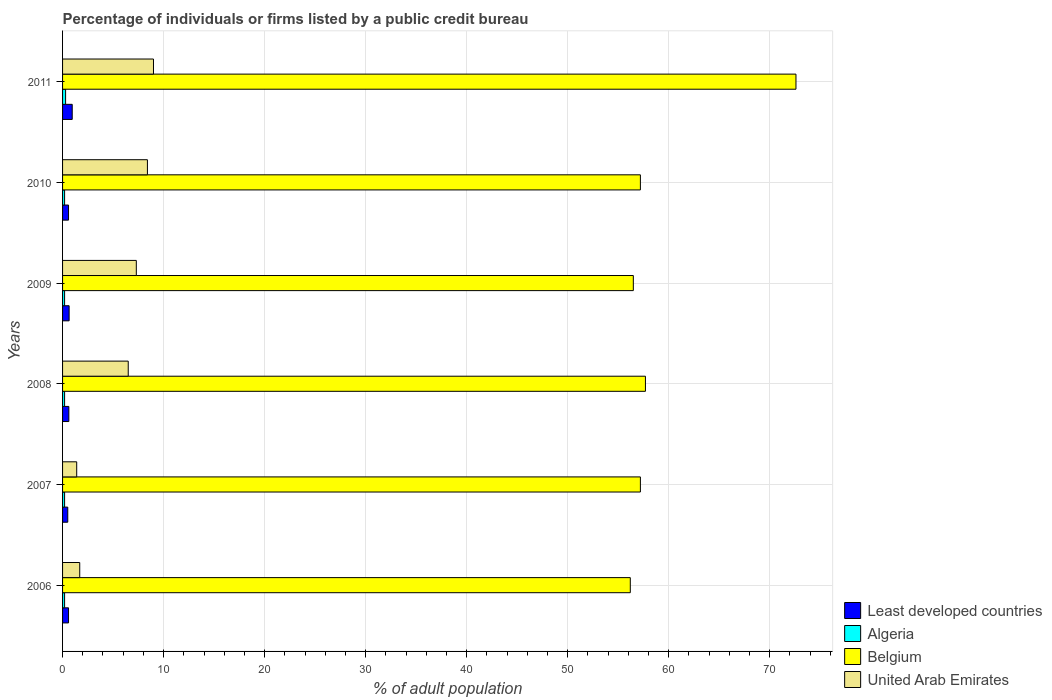How many bars are there on the 6th tick from the top?
Your answer should be compact. 4. How many bars are there on the 6th tick from the bottom?
Your answer should be very brief. 4. In how many cases, is the number of bars for a given year not equal to the number of legend labels?
Ensure brevity in your answer.  0. What is the percentage of population listed by a public credit bureau in Algeria in 2006?
Your response must be concise. 0.2. Across all years, what is the minimum percentage of population listed by a public credit bureau in United Arab Emirates?
Offer a very short reply. 1.4. What is the total percentage of population listed by a public credit bureau in United Arab Emirates in the graph?
Your answer should be very brief. 34.3. What is the difference between the percentage of population listed by a public credit bureau in Belgium in 2008 and that in 2009?
Your answer should be compact. 1.2. What is the difference between the percentage of population listed by a public credit bureau in Belgium in 2011 and the percentage of population listed by a public credit bureau in United Arab Emirates in 2008?
Keep it short and to the point. 66.1. What is the average percentage of population listed by a public credit bureau in Algeria per year?
Keep it short and to the point. 0.22. In the year 2011, what is the difference between the percentage of population listed by a public credit bureau in Belgium and percentage of population listed by a public credit bureau in Algeria?
Offer a very short reply. 72.3. What is the ratio of the percentage of population listed by a public credit bureau in Least developed countries in 2009 to that in 2010?
Your answer should be very brief. 1.1. Is the percentage of population listed by a public credit bureau in Belgium in 2009 less than that in 2010?
Your answer should be compact. Yes. What is the difference between the highest and the second highest percentage of population listed by a public credit bureau in Algeria?
Offer a terse response. 0.1. What is the difference between the highest and the lowest percentage of population listed by a public credit bureau in Belgium?
Your response must be concise. 16.4. Is it the case that in every year, the sum of the percentage of population listed by a public credit bureau in United Arab Emirates and percentage of population listed by a public credit bureau in Least developed countries is greater than the sum of percentage of population listed by a public credit bureau in Algeria and percentage of population listed by a public credit bureau in Belgium?
Provide a short and direct response. Yes. What does the 4th bar from the top in 2008 represents?
Your response must be concise. Least developed countries. What does the 1st bar from the bottom in 2009 represents?
Your answer should be compact. Least developed countries. Are all the bars in the graph horizontal?
Provide a short and direct response. Yes. How many years are there in the graph?
Give a very brief answer. 6. What is the difference between two consecutive major ticks on the X-axis?
Offer a very short reply. 10. How many legend labels are there?
Keep it short and to the point. 4. What is the title of the graph?
Give a very brief answer. Percentage of individuals or firms listed by a public credit bureau. Does "Middle East & North Africa (developing only)" appear as one of the legend labels in the graph?
Offer a very short reply. No. What is the label or title of the X-axis?
Offer a very short reply. % of adult population. What is the % of adult population in Least developed countries in 2006?
Make the answer very short. 0.59. What is the % of adult population of Algeria in 2006?
Provide a succinct answer. 0.2. What is the % of adult population of Belgium in 2006?
Keep it short and to the point. 56.2. What is the % of adult population of United Arab Emirates in 2006?
Provide a succinct answer. 1.7. What is the % of adult population in Least developed countries in 2007?
Offer a very short reply. 0.51. What is the % of adult population of Belgium in 2007?
Your answer should be compact. 57.2. What is the % of adult population of Least developed countries in 2008?
Keep it short and to the point. 0.62. What is the % of adult population in Belgium in 2008?
Ensure brevity in your answer.  57.7. What is the % of adult population in United Arab Emirates in 2008?
Give a very brief answer. 6.5. What is the % of adult population in Least developed countries in 2009?
Your answer should be very brief. 0.65. What is the % of adult population in Algeria in 2009?
Ensure brevity in your answer.  0.2. What is the % of adult population of Belgium in 2009?
Make the answer very short. 56.5. What is the % of adult population in United Arab Emirates in 2009?
Make the answer very short. 7.3. What is the % of adult population of Least developed countries in 2010?
Give a very brief answer. 0.59. What is the % of adult population in Belgium in 2010?
Offer a terse response. 57.2. What is the % of adult population of United Arab Emirates in 2010?
Your response must be concise. 8.4. What is the % of adult population of Least developed countries in 2011?
Your response must be concise. 0.96. What is the % of adult population of Belgium in 2011?
Offer a very short reply. 72.6. What is the % of adult population of United Arab Emirates in 2011?
Offer a very short reply. 9. Across all years, what is the maximum % of adult population in Least developed countries?
Your answer should be compact. 0.96. Across all years, what is the maximum % of adult population of Belgium?
Keep it short and to the point. 72.6. Across all years, what is the maximum % of adult population in United Arab Emirates?
Ensure brevity in your answer.  9. Across all years, what is the minimum % of adult population of Least developed countries?
Offer a terse response. 0.51. Across all years, what is the minimum % of adult population of Algeria?
Provide a succinct answer. 0.2. Across all years, what is the minimum % of adult population in Belgium?
Make the answer very short. 56.2. Across all years, what is the minimum % of adult population of United Arab Emirates?
Keep it short and to the point. 1.4. What is the total % of adult population in Least developed countries in the graph?
Your response must be concise. 3.92. What is the total % of adult population in Belgium in the graph?
Make the answer very short. 357.4. What is the total % of adult population in United Arab Emirates in the graph?
Provide a succinct answer. 34.3. What is the difference between the % of adult population of Least developed countries in 2006 and that in 2007?
Give a very brief answer. 0.08. What is the difference between the % of adult population of Algeria in 2006 and that in 2007?
Make the answer very short. 0. What is the difference between the % of adult population in Belgium in 2006 and that in 2007?
Offer a very short reply. -1. What is the difference between the % of adult population in United Arab Emirates in 2006 and that in 2007?
Offer a very short reply. 0.3. What is the difference between the % of adult population in Least developed countries in 2006 and that in 2008?
Your answer should be very brief. -0.03. What is the difference between the % of adult population of Algeria in 2006 and that in 2008?
Ensure brevity in your answer.  0. What is the difference between the % of adult population of Least developed countries in 2006 and that in 2009?
Give a very brief answer. -0.06. What is the difference between the % of adult population of Algeria in 2006 and that in 2009?
Keep it short and to the point. 0. What is the difference between the % of adult population of Algeria in 2006 and that in 2010?
Keep it short and to the point. 0. What is the difference between the % of adult population of Belgium in 2006 and that in 2010?
Your response must be concise. -1. What is the difference between the % of adult population of Least developed countries in 2006 and that in 2011?
Provide a short and direct response. -0.37. What is the difference between the % of adult population of Belgium in 2006 and that in 2011?
Your answer should be compact. -16.4. What is the difference between the % of adult population in United Arab Emirates in 2006 and that in 2011?
Provide a short and direct response. -7.3. What is the difference between the % of adult population in Least developed countries in 2007 and that in 2008?
Keep it short and to the point. -0.11. What is the difference between the % of adult population of Algeria in 2007 and that in 2008?
Provide a short and direct response. 0. What is the difference between the % of adult population of Least developed countries in 2007 and that in 2009?
Ensure brevity in your answer.  -0.13. What is the difference between the % of adult population of Algeria in 2007 and that in 2009?
Offer a terse response. 0. What is the difference between the % of adult population of Belgium in 2007 and that in 2009?
Your response must be concise. 0.7. What is the difference between the % of adult population of United Arab Emirates in 2007 and that in 2009?
Your answer should be compact. -5.9. What is the difference between the % of adult population in Least developed countries in 2007 and that in 2010?
Offer a very short reply. -0.08. What is the difference between the % of adult population of Least developed countries in 2007 and that in 2011?
Keep it short and to the point. -0.44. What is the difference between the % of adult population of Algeria in 2007 and that in 2011?
Provide a short and direct response. -0.1. What is the difference between the % of adult population of Belgium in 2007 and that in 2011?
Keep it short and to the point. -15.4. What is the difference between the % of adult population in Least developed countries in 2008 and that in 2009?
Make the answer very short. -0.03. What is the difference between the % of adult population of Least developed countries in 2008 and that in 2010?
Ensure brevity in your answer.  0.03. What is the difference between the % of adult population of Algeria in 2008 and that in 2010?
Ensure brevity in your answer.  0. What is the difference between the % of adult population of Least developed countries in 2008 and that in 2011?
Give a very brief answer. -0.33. What is the difference between the % of adult population of Belgium in 2008 and that in 2011?
Offer a terse response. -14.9. What is the difference between the % of adult population in United Arab Emirates in 2008 and that in 2011?
Offer a terse response. -2.5. What is the difference between the % of adult population of Least developed countries in 2009 and that in 2010?
Make the answer very short. 0.06. What is the difference between the % of adult population in Algeria in 2009 and that in 2010?
Offer a very short reply. 0. What is the difference between the % of adult population in Belgium in 2009 and that in 2010?
Offer a terse response. -0.7. What is the difference between the % of adult population of Least developed countries in 2009 and that in 2011?
Your answer should be very brief. -0.31. What is the difference between the % of adult population of Belgium in 2009 and that in 2011?
Your answer should be very brief. -16.1. What is the difference between the % of adult population of Least developed countries in 2010 and that in 2011?
Make the answer very short. -0.37. What is the difference between the % of adult population in Belgium in 2010 and that in 2011?
Keep it short and to the point. -15.4. What is the difference between the % of adult population in United Arab Emirates in 2010 and that in 2011?
Your answer should be compact. -0.6. What is the difference between the % of adult population in Least developed countries in 2006 and the % of adult population in Algeria in 2007?
Give a very brief answer. 0.39. What is the difference between the % of adult population in Least developed countries in 2006 and the % of adult population in Belgium in 2007?
Offer a very short reply. -56.61. What is the difference between the % of adult population of Least developed countries in 2006 and the % of adult population of United Arab Emirates in 2007?
Your answer should be compact. -0.81. What is the difference between the % of adult population of Algeria in 2006 and the % of adult population of Belgium in 2007?
Provide a succinct answer. -57. What is the difference between the % of adult population of Algeria in 2006 and the % of adult population of United Arab Emirates in 2007?
Your response must be concise. -1.2. What is the difference between the % of adult population in Belgium in 2006 and the % of adult population in United Arab Emirates in 2007?
Offer a very short reply. 54.8. What is the difference between the % of adult population in Least developed countries in 2006 and the % of adult population in Algeria in 2008?
Give a very brief answer. 0.39. What is the difference between the % of adult population of Least developed countries in 2006 and the % of adult population of Belgium in 2008?
Offer a terse response. -57.11. What is the difference between the % of adult population in Least developed countries in 2006 and the % of adult population in United Arab Emirates in 2008?
Your answer should be very brief. -5.91. What is the difference between the % of adult population of Algeria in 2006 and the % of adult population of Belgium in 2008?
Your answer should be very brief. -57.5. What is the difference between the % of adult population in Belgium in 2006 and the % of adult population in United Arab Emirates in 2008?
Provide a short and direct response. 49.7. What is the difference between the % of adult population in Least developed countries in 2006 and the % of adult population in Algeria in 2009?
Your answer should be compact. 0.39. What is the difference between the % of adult population in Least developed countries in 2006 and the % of adult population in Belgium in 2009?
Give a very brief answer. -55.91. What is the difference between the % of adult population of Least developed countries in 2006 and the % of adult population of United Arab Emirates in 2009?
Offer a very short reply. -6.71. What is the difference between the % of adult population in Algeria in 2006 and the % of adult population in Belgium in 2009?
Offer a very short reply. -56.3. What is the difference between the % of adult population in Algeria in 2006 and the % of adult population in United Arab Emirates in 2009?
Provide a succinct answer. -7.1. What is the difference between the % of adult population of Belgium in 2006 and the % of adult population of United Arab Emirates in 2009?
Your answer should be compact. 48.9. What is the difference between the % of adult population of Least developed countries in 2006 and the % of adult population of Algeria in 2010?
Ensure brevity in your answer.  0.39. What is the difference between the % of adult population of Least developed countries in 2006 and the % of adult population of Belgium in 2010?
Provide a short and direct response. -56.61. What is the difference between the % of adult population in Least developed countries in 2006 and the % of adult population in United Arab Emirates in 2010?
Keep it short and to the point. -7.81. What is the difference between the % of adult population of Algeria in 2006 and the % of adult population of Belgium in 2010?
Ensure brevity in your answer.  -57. What is the difference between the % of adult population of Algeria in 2006 and the % of adult population of United Arab Emirates in 2010?
Your answer should be very brief. -8.2. What is the difference between the % of adult population in Belgium in 2006 and the % of adult population in United Arab Emirates in 2010?
Provide a succinct answer. 47.8. What is the difference between the % of adult population in Least developed countries in 2006 and the % of adult population in Algeria in 2011?
Offer a terse response. 0.29. What is the difference between the % of adult population in Least developed countries in 2006 and the % of adult population in Belgium in 2011?
Keep it short and to the point. -72.01. What is the difference between the % of adult population in Least developed countries in 2006 and the % of adult population in United Arab Emirates in 2011?
Ensure brevity in your answer.  -8.41. What is the difference between the % of adult population of Algeria in 2006 and the % of adult population of Belgium in 2011?
Your answer should be compact. -72.4. What is the difference between the % of adult population in Belgium in 2006 and the % of adult population in United Arab Emirates in 2011?
Ensure brevity in your answer.  47.2. What is the difference between the % of adult population in Least developed countries in 2007 and the % of adult population in Algeria in 2008?
Your answer should be very brief. 0.31. What is the difference between the % of adult population in Least developed countries in 2007 and the % of adult population in Belgium in 2008?
Give a very brief answer. -57.19. What is the difference between the % of adult population in Least developed countries in 2007 and the % of adult population in United Arab Emirates in 2008?
Offer a terse response. -5.99. What is the difference between the % of adult population in Algeria in 2007 and the % of adult population in Belgium in 2008?
Your answer should be compact. -57.5. What is the difference between the % of adult population in Belgium in 2007 and the % of adult population in United Arab Emirates in 2008?
Give a very brief answer. 50.7. What is the difference between the % of adult population of Least developed countries in 2007 and the % of adult population of Algeria in 2009?
Your response must be concise. 0.31. What is the difference between the % of adult population of Least developed countries in 2007 and the % of adult population of Belgium in 2009?
Offer a very short reply. -55.99. What is the difference between the % of adult population of Least developed countries in 2007 and the % of adult population of United Arab Emirates in 2009?
Ensure brevity in your answer.  -6.79. What is the difference between the % of adult population in Algeria in 2007 and the % of adult population in Belgium in 2009?
Provide a succinct answer. -56.3. What is the difference between the % of adult population in Algeria in 2007 and the % of adult population in United Arab Emirates in 2009?
Ensure brevity in your answer.  -7.1. What is the difference between the % of adult population in Belgium in 2007 and the % of adult population in United Arab Emirates in 2009?
Offer a terse response. 49.9. What is the difference between the % of adult population of Least developed countries in 2007 and the % of adult population of Algeria in 2010?
Make the answer very short. 0.31. What is the difference between the % of adult population of Least developed countries in 2007 and the % of adult population of Belgium in 2010?
Provide a succinct answer. -56.69. What is the difference between the % of adult population of Least developed countries in 2007 and the % of adult population of United Arab Emirates in 2010?
Offer a very short reply. -7.89. What is the difference between the % of adult population of Algeria in 2007 and the % of adult population of Belgium in 2010?
Your answer should be compact. -57. What is the difference between the % of adult population in Algeria in 2007 and the % of adult population in United Arab Emirates in 2010?
Your response must be concise. -8.2. What is the difference between the % of adult population in Belgium in 2007 and the % of adult population in United Arab Emirates in 2010?
Your response must be concise. 48.8. What is the difference between the % of adult population in Least developed countries in 2007 and the % of adult population in Algeria in 2011?
Offer a terse response. 0.21. What is the difference between the % of adult population in Least developed countries in 2007 and the % of adult population in Belgium in 2011?
Your answer should be compact. -72.09. What is the difference between the % of adult population of Least developed countries in 2007 and the % of adult population of United Arab Emirates in 2011?
Provide a succinct answer. -8.49. What is the difference between the % of adult population of Algeria in 2007 and the % of adult population of Belgium in 2011?
Offer a terse response. -72.4. What is the difference between the % of adult population in Algeria in 2007 and the % of adult population in United Arab Emirates in 2011?
Your answer should be very brief. -8.8. What is the difference between the % of adult population in Belgium in 2007 and the % of adult population in United Arab Emirates in 2011?
Your answer should be compact. 48.2. What is the difference between the % of adult population in Least developed countries in 2008 and the % of adult population in Algeria in 2009?
Keep it short and to the point. 0.42. What is the difference between the % of adult population in Least developed countries in 2008 and the % of adult population in Belgium in 2009?
Your answer should be very brief. -55.88. What is the difference between the % of adult population of Least developed countries in 2008 and the % of adult population of United Arab Emirates in 2009?
Offer a terse response. -6.68. What is the difference between the % of adult population in Algeria in 2008 and the % of adult population in Belgium in 2009?
Offer a very short reply. -56.3. What is the difference between the % of adult population in Belgium in 2008 and the % of adult population in United Arab Emirates in 2009?
Provide a short and direct response. 50.4. What is the difference between the % of adult population in Least developed countries in 2008 and the % of adult population in Algeria in 2010?
Provide a short and direct response. 0.42. What is the difference between the % of adult population of Least developed countries in 2008 and the % of adult population of Belgium in 2010?
Provide a succinct answer. -56.58. What is the difference between the % of adult population in Least developed countries in 2008 and the % of adult population in United Arab Emirates in 2010?
Your response must be concise. -7.78. What is the difference between the % of adult population of Algeria in 2008 and the % of adult population of Belgium in 2010?
Your answer should be compact. -57. What is the difference between the % of adult population of Belgium in 2008 and the % of adult population of United Arab Emirates in 2010?
Ensure brevity in your answer.  49.3. What is the difference between the % of adult population in Least developed countries in 2008 and the % of adult population in Algeria in 2011?
Offer a terse response. 0.32. What is the difference between the % of adult population in Least developed countries in 2008 and the % of adult population in Belgium in 2011?
Your response must be concise. -71.98. What is the difference between the % of adult population in Least developed countries in 2008 and the % of adult population in United Arab Emirates in 2011?
Your response must be concise. -8.38. What is the difference between the % of adult population in Algeria in 2008 and the % of adult population in Belgium in 2011?
Offer a very short reply. -72.4. What is the difference between the % of adult population in Belgium in 2008 and the % of adult population in United Arab Emirates in 2011?
Provide a short and direct response. 48.7. What is the difference between the % of adult population of Least developed countries in 2009 and the % of adult population of Algeria in 2010?
Provide a succinct answer. 0.45. What is the difference between the % of adult population in Least developed countries in 2009 and the % of adult population in Belgium in 2010?
Keep it short and to the point. -56.55. What is the difference between the % of adult population of Least developed countries in 2009 and the % of adult population of United Arab Emirates in 2010?
Keep it short and to the point. -7.75. What is the difference between the % of adult population of Algeria in 2009 and the % of adult population of Belgium in 2010?
Provide a succinct answer. -57. What is the difference between the % of adult population in Belgium in 2009 and the % of adult population in United Arab Emirates in 2010?
Keep it short and to the point. 48.1. What is the difference between the % of adult population in Least developed countries in 2009 and the % of adult population in Algeria in 2011?
Your answer should be very brief. 0.35. What is the difference between the % of adult population in Least developed countries in 2009 and the % of adult population in Belgium in 2011?
Make the answer very short. -71.95. What is the difference between the % of adult population in Least developed countries in 2009 and the % of adult population in United Arab Emirates in 2011?
Your answer should be very brief. -8.35. What is the difference between the % of adult population in Algeria in 2009 and the % of adult population in Belgium in 2011?
Provide a succinct answer. -72.4. What is the difference between the % of adult population in Belgium in 2009 and the % of adult population in United Arab Emirates in 2011?
Keep it short and to the point. 47.5. What is the difference between the % of adult population of Least developed countries in 2010 and the % of adult population of Algeria in 2011?
Offer a terse response. 0.29. What is the difference between the % of adult population in Least developed countries in 2010 and the % of adult population in Belgium in 2011?
Keep it short and to the point. -72.01. What is the difference between the % of adult population of Least developed countries in 2010 and the % of adult population of United Arab Emirates in 2011?
Your answer should be compact. -8.41. What is the difference between the % of adult population of Algeria in 2010 and the % of adult population of Belgium in 2011?
Ensure brevity in your answer.  -72.4. What is the difference between the % of adult population in Belgium in 2010 and the % of adult population in United Arab Emirates in 2011?
Give a very brief answer. 48.2. What is the average % of adult population of Least developed countries per year?
Ensure brevity in your answer.  0.65. What is the average % of adult population in Algeria per year?
Offer a very short reply. 0.22. What is the average % of adult population of Belgium per year?
Offer a terse response. 59.57. What is the average % of adult population of United Arab Emirates per year?
Provide a short and direct response. 5.72. In the year 2006, what is the difference between the % of adult population of Least developed countries and % of adult population of Algeria?
Offer a terse response. 0.39. In the year 2006, what is the difference between the % of adult population of Least developed countries and % of adult population of Belgium?
Keep it short and to the point. -55.61. In the year 2006, what is the difference between the % of adult population of Least developed countries and % of adult population of United Arab Emirates?
Your answer should be very brief. -1.11. In the year 2006, what is the difference between the % of adult population of Algeria and % of adult population of Belgium?
Your answer should be very brief. -56. In the year 2006, what is the difference between the % of adult population in Belgium and % of adult population in United Arab Emirates?
Provide a short and direct response. 54.5. In the year 2007, what is the difference between the % of adult population of Least developed countries and % of adult population of Algeria?
Offer a terse response. 0.31. In the year 2007, what is the difference between the % of adult population of Least developed countries and % of adult population of Belgium?
Offer a terse response. -56.69. In the year 2007, what is the difference between the % of adult population in Least developed countries and % of adult population in United Arab Emirates?
Provide a succinct answer. -0.89. In the year 2007, what is the difference between the % of adult population of Algeria and % of adult population of Belgium?
Your answer should be compact. -57. In the year 2007, what is the difference between the % of adult population of Algeria and % of adult population of United Arab Emirates?
Your answer should be compact. -1.2. In the year 2007, what is the difference between the % of adult population of Belgium and % of adult population of United Arab Emirates?
Your answer should be compact. 55.8. In the year 2008, what is the difference between the % of adult population of Least developed countries and % of adult population of Algeria?
Offer a terse response. 0.42. In the year 2008, what is the difference between the % of adult population in Least developed countries and % of adult population in Belgium?
Your answer should be compact. -57.08. In the year 2008, what is the difference between the % of adult population in Least developed countries and % of adult population in United Arab Emirates?
Your response must be concise. -5.88. In the year 2008, what is the difference between the % of adult population of Algeria and % of adult population of Belgium?
Offer a very short reply. -57.5. In the year 2008, what is the difference between the % of adult population in Belgium and % of adult population in United Arab Emirates?
Your response must be concise. 51.2. In the year 2009, what is the difference between the % of adult population of Least developed countries and % of adult population of Algeria?
Offer a terse response. 0.45. In the year 2009, what is the difference between the % of adult population in Least developed countries and % of adult population in Belgium?
Your response must be concise. -55.85. In the year 2009, what is the difference between the % of adult population in Least developed countries and % of adult population in United Arab Emirates?
Your answer should be compact. -6.65. In the year 2009, what is the difference between the % of adult population in Algeria and % of adult population in Belgium?
Offer a very short reply. -56.3. In the year 2009, what is the difference between the % of adult population of Belgium and % of adult population of United Arab Emirates?
Your answer should be very brief. 49.2. In the year 2010, what is the difference between the % of adult population in Least developed countries and % of adult population in Algeria?
Your answer should be compact. 0.39. In the year 2010, what is the difference between the % of adult population of Least developed countries and % of adult population of Belgium?
Keep it short and to the point. -56.61. In the year 2010, what is the difference between the % of adult population of Least developed countries and % of adult population of United Arab Emirates?
Keep it short and to the point. -7.81. In the year 2010, what is the difference between the % of adult population of Algeria and % of adult population of Belgium?
Give a very brief answer. -57. In the year 2010, what is the difference between the % of adult population of Algeria and % of adult population of United Arab Emirates?
Give a very brief answer. -8.2. In the year 2010, what is the difference between the % of adult population of Belgium and % of adult population of United Arab Emirates?
Ensure brevity in your answer.  48.8. In the year 2011, what is the difference between the % of adult population of Least developed countries and % of adult population of Algeria?
Make the answer very short. 0.66. In the year 2011, what is the difference between the % of adult population in Least developed countries and % of adult population in Belgium?
Ensure brevity in your answer.  -71.64. In the year 2011, what is the difference between the % of adult population of Least developed countries and % of adult population of United Arab Emirates?
Give a very brief answer. -8.04. In the year 2011, what is the difference between the % of adult population of Algeria and % of adult population of Belgium?
Your answer should be very brief. -72.3. In the year 2011, what is the difference between the % of adult population in Algeria and % of adult population in United Arab Emirates?
Ensure brevity in your answer.  -8.7. In the year 2011, what is the difference between the % of adult population in Belgium and % of adult population in United Arab Emirates?
Your answer should be compact. 63.6. What is the ratio of the % of adult population of Least developed countries in 2006 to that in 2007?
Keep it short and to the point. 1.15. What is the ratio of the % of adult population in Algeria in 2006 to that in 2007?
Ensure brevity in your answer.  1. What is the ratio of the % of adult population in Belgium in 2006 to that in 2007?
Provide a succinct answer. 0.98. What is the ratio of the % of adult population of United Arab Emirates in 2006 to that in 2007?
Provide a succinct answer. 1.21. What is the ratio of the % of adult population of Least developed countries in 2006 to that in 2008?
Keep it short and to the point. 0.95. What is the ratio of the % of adult population in Belgium in 2006 to that in 2008?
Provide a succinct answer. 0.97. What is the ratio of the % of adult population in United Arab Emirates in 2006 to that in 2008?
Give a very brief answer. 0.26. What is the ratio of the % of adult population of Least developed countries in 2006 to that in 2009?
Your answer should be very brief. 0.91. What is the ratio of the % of adult population of Algeria in 2006 to that in 2009?
Ensure brevity in your answer.  1. What is the ratio of the % of adult population in Belgium in 2006 to that in 2009?
Give a very brief answer. 0.99. What is the ratio of the % of adult population in United Arab Emirates in 2006 to that in 2009?
Provide a short and direct response. 0.23. What is the ratio of the % of adult population of Algeria in 2006 to that in 2010?
Give a very brief answer. 1. What is the ratio of the % of adult population of Belgium in 2006 to that in 2010?
Offer a terse response. 0.98. What is the ratio of the % of adult population in United Arab Emirates in 2006 to that in 2010?
Offer a very short reply. 0.2. What is the ratio of the % of adult population of Least developed countries in 2006 to that in 2011?
Give a very brief answer. 0.62. What is the ratio of the % of adult population of Belgium in 2006 to that in 2011?
Your response must be concise. 0.77. What is the ratio of the % of adult population of United Arab Emirates in 2006 to that in 2011?
Your response must be concise. 0.19. What is the ratio of the % of adult population in Least developed countries in 2007 to that in 2008?
Your answer should be compact. 0.83. What is the ratio of the % of adult population in Belgium in 2007 to that in 2008?
Keep it short and to the point. 0.99. What is the ratio of the % of adult population of United Arab Emirates in 2007 to that in 2008?
Offer a terse response. 0.22. What is the ratio of the % of adult population in Least developed countries in 2007 to that in 2009?
Your answer should be compact. 0.79. What is the ratio of the % of adult population of Belgium in 2007 to that in 2009?
Offer a terse response. 1.01. What is the ratio of the % of adult population of United Arab Emirates in 2007 to that in 2009?
Provide a short and direct response. 0.19. What is the ratio of the % of adult population of Least developed countries in 2007 to that in 2010?
Offer a very short reply. 0.87. What is the ratio of the % of adult population in Algeria in 2007 to that in 2010?
Make the answer very short. 1. What is the ratio of the % of adult population of Belgium in 2007 to that in 2010?
Your response must be concise. 1. What is the ratio of the % of adult population in United Arab Emirates in 2007 to that in 2010?
Provide a short and direct response. 0.17. What is the ratio of the % of adult population in Least developed countries in 2007 to that in 2011?
Ensure brevity in your answer.  0.54. What is the ratio of the % of adult population in Belgium in 2007 to that in 2011?
Provide a short and direct response. 0.79. What is the ratio of the % of adult population in United Arab Emirates in 2007 to that in 2011?
Provide a short and direct response. 0.16. What is the ratio of the % of adult population in Algeria in 2008 to that in 2009?
Ensure brevity in your answer.  1. What is the ratio of the % of adult population of Belgium in 2008 to that in 2009?
Provide a succinct answer. 1.02. What is the ratio of the % of adult population of United Arab Emirates in 2008 to that in 2009?
Give a very brief answer. 0.89. What is the ratio of the % of adult population of Least developed countries in 2008 to that in 2010?
Your answer should be compact. 1.05. What is the ratio of the % of adult population in Algeria in 2008 to that in 2010?
Give a very brief answer. 1. What is the ratio of the % of adult population of Belgium in 2008 to that in 2010?
Ensure brevity in your answer.  1.01. What is the ratio of the % of adult population of United Arab Emirates in 2008 to that in 2010?
Offer a very short reply. 0.77. What is the ratio of the % of adult population of Least developed countries in 2008 to that in 2011?
Make the answer very short. 0.65. What is the ratio of the % of adult population in Algeria in 2008 to that in 2011?
Your response must be concise. 0.67. What is the ratio of the % of adult population in Belgium in 2008 to that in 2011?
Keep it short and to the point. 0.79. What is the ratio of the % of adult population in United Arab Emirates in 2008 to that in 2011?
Your response must be concise. 0.72. What is the ratio of the % of adult population of Least developed countries in 2009 to that in 2010?
Keep it short and to the point. 1.1. What is the ratio of the % of adult population in Belgium in 2009 to that in 2010?
Offer a very short reply. 0.99. What is the ratio of the % of adult population of United Arab Emirates in 2009 to that in 2010?
Provide a succinct answer. 0.87. What is the ratio of the % of adult population of Least developed countries in 2009 to that in 2011?
Provide a short and direct response. 0.68. What is the ratio of the % of adult population of Belgium in 2009 to that in 2011?
Your answer should be very brief. 0.78. What is the ratio of the % of adult population of United Arab Emirates in 2009 to that in 2011?
Keep it short and to the point. 0.81. What is the ratio of the % of adult population of Least developed countries in 2010 to that in 2011?
Give a very brief answer. 0.62. What is the ratio of the % of adult population of Algeria in 2010 to that in 2011?
Your answer should be compact. 0.67. What is the ratio of the % of adult population of Belgium in 2010 to that in 2011?
Offer a terse response. 0.79. What is the ratio of the % of adult population of United Arab Emirates in 2010 to that in 2011?
Offer a terse response. 0.93. What is the difference between the highest and the second highest % of adult population in Least developed countries?
Provide a succinct answer. 0.31. What is the difference between the highest and the lowest % of adult population in Least developed countries?
Offer a very short reply. 0.44. What is the difference between the highest and the lowest % of adult population in United Arab Emirates?
Offer a terse response. 7.6. 